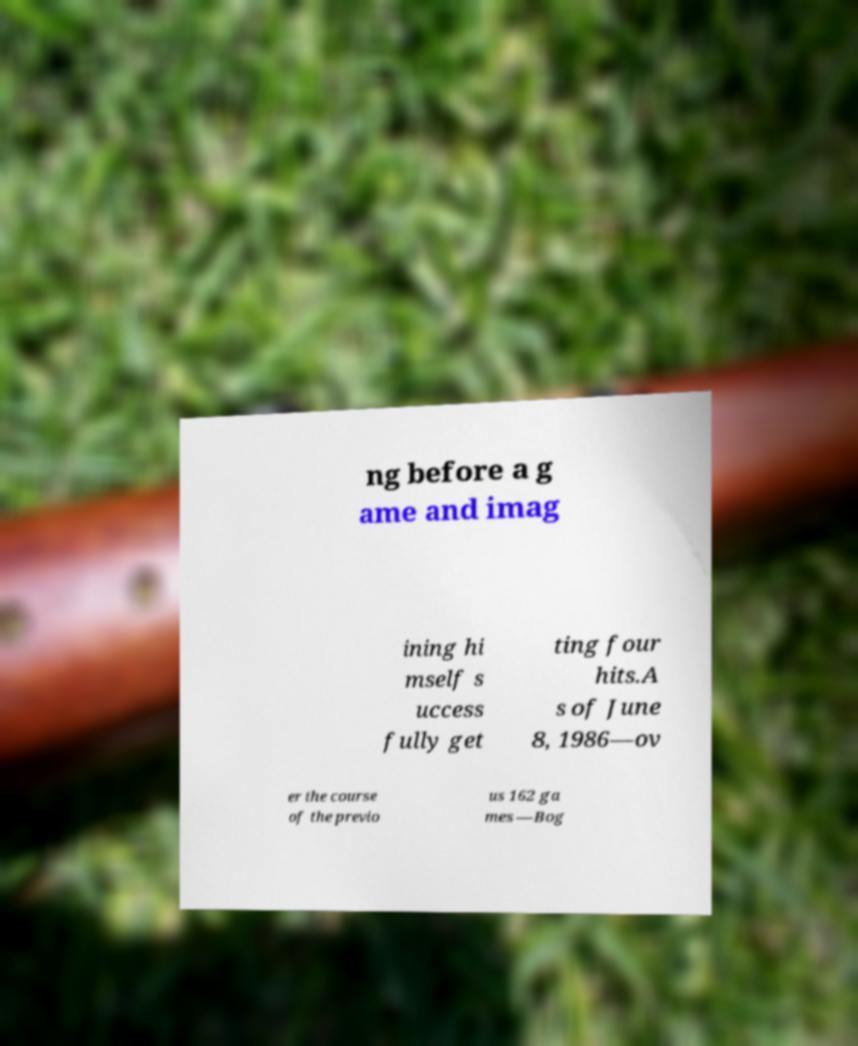Please identify and transcribe the text found in this image. ng before a g ame and imag ining hi mself s uccess fully get ting four hits.A s of June 8, 1986—ov er the course of the previo us 162 ga mes —Bog 